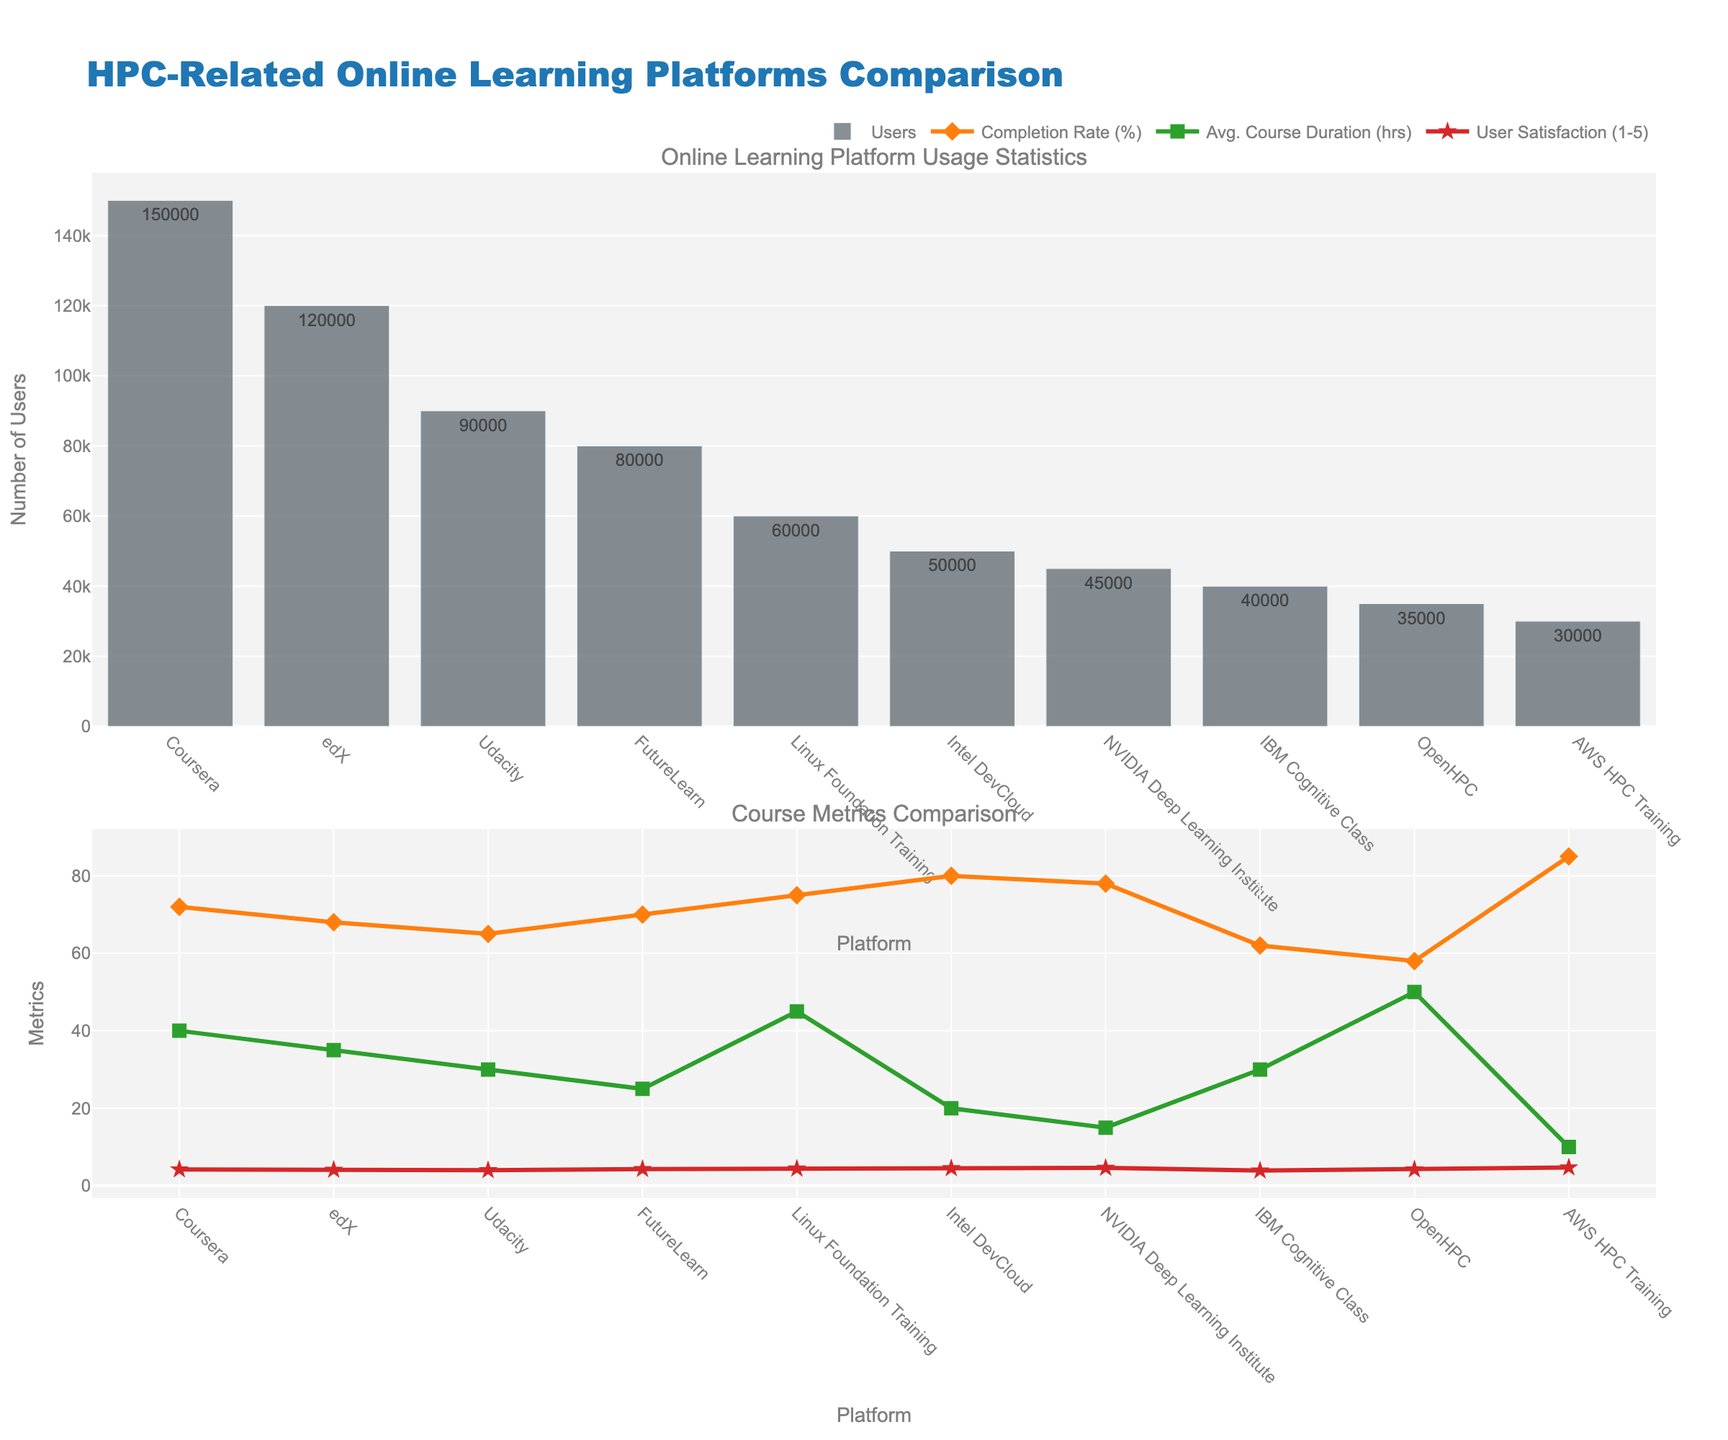Which platform has the highest number of users? Look at the first subplot showing the number of users for each platform. The tallest bar represents the platform with the highest number of users.
Answer: Coursera What are the average course duration and user satisfaction for Intel DevCloud? Refer to the second subplot. Look for the data points corresponding to Intel DevCloud under 'Avg. Course Duration (hrs)' and 'User Satisfaction (1-5)'.
Answer: 20 hours, 4.5 Which platform has the lowest completion rate, and what is its percent? In the second subplot, check the 'Completion Rate (%)' line graph for the lowest point and identify the corresponding platform.
Answer: OpenHPC, 58% Compare the user satisfaction between NVIDIA Deep Learning Institute and AWS HPC Training. Which one is higher? In the second subplot, compare the 'User Satisfaction (1-5)' line graph data points for these two platforms. The higher point indicates higher satisfaction.
Answer: AWS HPC Training By how many hours is the average course duration of OpenHPC longer than that of AWS HPC Training? Subtract the average course duration of AWS HPC Training from OpenHPC, both of which can be found in the second subplot.
Answer: 40 hours Which platform has a higher number of users: IBM Cognitive Class or Linux Foundation Training? In the first subplot, compare the height of the bars representing these two platforms. The taller bar indicates a higher number of users.
Answer: Linux Foundation Training Is the completion rate of Linux Foundation Training higher than FutureLearn? Compare the 'Completion Rate (%)' line graph data points for these two platforms in the second subplot. The higher point indicates a higher completion rate.
Answer: Yes What is the difference in user satisfaction between OpenHPC and FutureLearn? In the second subplot, find the data points corresponding to each platform's 'User Satisfaction (1-5)', then calculate their difference.
Answer: 0.1 Which platform has the shortest average course duration, and what is the duration in hours? Look at the 'Avg. Course Duration (hrs)' line graph in the second subplot. Identify the lowest point and the corresponding platform.
Answer: AWS HPC Training, 10 hours What is the average completion rate of Coursera and edX? Look at the 'Completion Rate (%)' of Coursera and edX in the second subplot, sum them up and divide by 2.
Answer: 70% 